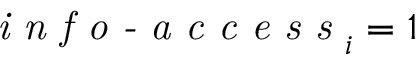<formula> <loc_0><loc_0><loc_500><loc_500>i n f o - a c c e s s _ { i } = 1</formula> 